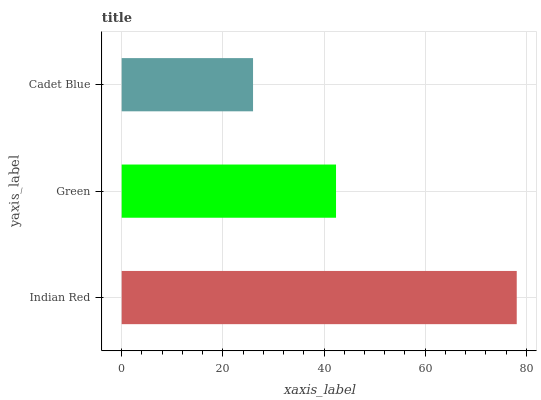Is Cadet Blue the minimum?
Answer yes or no. Yes. Is Indian Red the maximum?
Answer yes or no. Yes. Is Green the minimum?
Answer yes or no. No. Is Green the maximum?
Answer yes or no. No. Is Indian Red greater than Green?
Answer yes or no. Yes. Is Green less than Indian Red?
Answer yes or no. Yes. Is Green greater than Indian Red?
Answer yes or no. No. Is Indian Red less than Green?
Answer yes or no. No. Is Green the high median?
Answer yes or no. Yes. Is Green the low median?
Answer yes or no. Yes. Is Cadet Blue the high median?
Answer yes or no. No. Is Cadet Blue the low median?
Answer yes or no. No. 